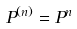Convert formula to latex. <formula><loc_0><loc_0><loc_500><loc_500>P ^ { ( n ) } = P ^ { n }</formula> 